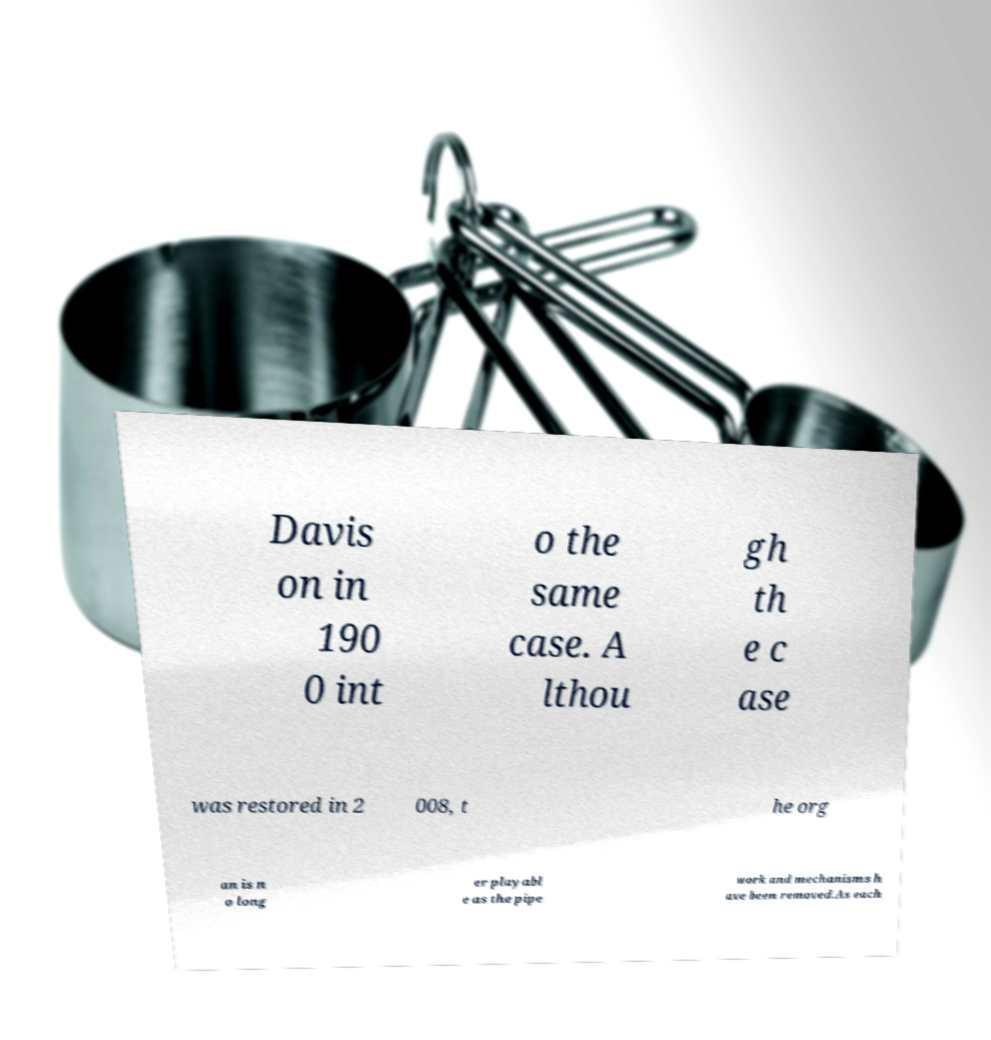Can you accurately transcribe the text from the provided image for me? Davis on in 190 0 int o the same case. A lthou gh th e c ase was restored in 2 008, t he org an is n o long er playabl e as the pipe work and mechanisms h ave been removed.As each 